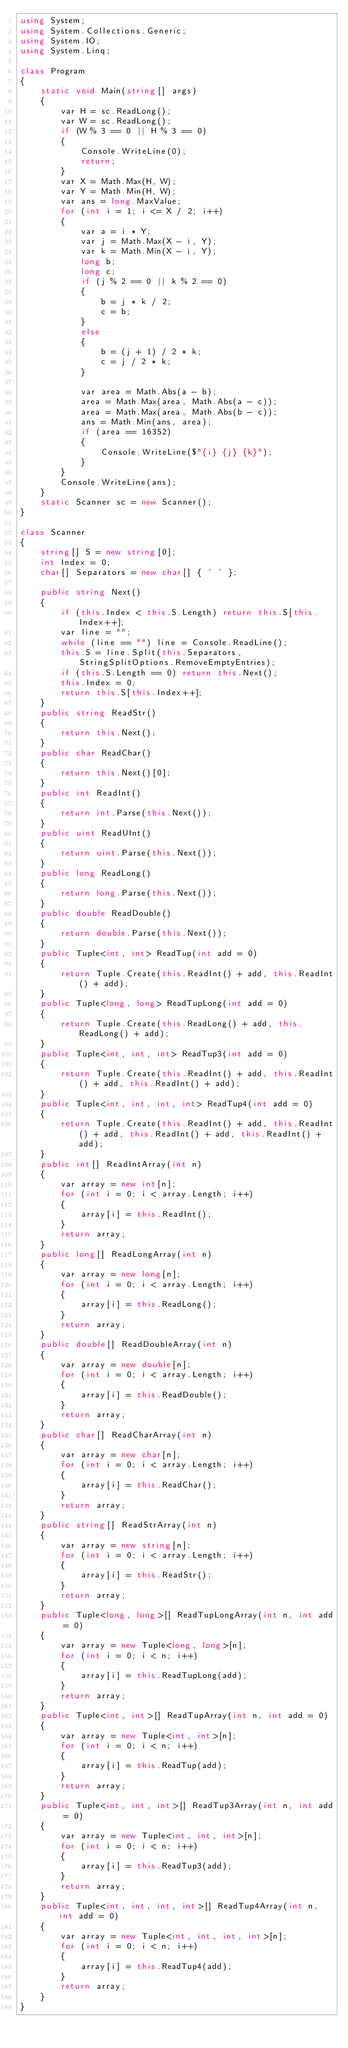<code> <loc_0><loc_0><loc_500><loc_500><_C#_>using System;
using System.Collections.Generic;
using System.IO;
using System.Linq;

class Program
{
    static void Main(string[] args)
    {
        var H = sc.ReadLong();
        var W = sc.ReadLong();
        if (W % 3 == 0 || H % 3 == 0)
        {
            Console.WriteLine(0);
            return;
        }
        var X = Math.Max(H, W);
        var Y = Math.Min(H, W);
        var ans = long.MaxValue;
        for (int i = 1; i <= X / 2; i++)
        {
            var a = i * Y;
            var j = Math.Max(X - i, Y);
            var k = Math.Min(X - i, Y);
            long b;
            long c;
            if (j % 2 == 0 || k % 2 == 0)
            {
                b = j * k / 2;
                c = b;
            }
            else
            {
                b = (j + 1) / 2 * k;
                c = j / 2 * k;
            }

            var area = Math.Abs(a - b);
            area = Math.Max(area, Math.Abs(a - c));
            area = Math.Max(area, Math.Abs(b - c));
            ans = Math.Min(ans, area);
            if (area == 16352)
            {
                Console.WriteLine($"{i} {j} {k}");
            }
        }
        Console.WriteLine(ans);
    }
    static Scanner sc = new Scanner();
}

class Scanner
{
    string[] S = new string[0];
    int Index = 0;
    char[] Separators = new char[] { ' ' };

    public string Next()
    {
        if (this.Index < this.S.Length) return this.S[this.Index++];
        var line = "";
        while (line == "") line = Console.ReadLine();
        this.S = line.Split(this.Separators, StringSplitOptions.RemoveEmptyEntries);
        if (this.S.Length == 0) return this.Next();
        this.Index = 0;
        return this.S[this.Index++];
    }
    public string ReadStr()
    {
        return this.Next();
    }
    public char ReadChar()
    {
        return this.Next()[0];
    }
    public int ReadInt()
    {
        return int.Parse(this.Next());
    }
    public uint ReadUInt()
    {
        return uint.Parse(this.Next());
    }
    public long ReadLong()
    {
        return long.Parse(this.Next());
    }
    public double ReadDouble()
    {
        return double.Parse(this.Next());
    }
    public Tuple<int, int> ReadTup(int add = 0)
    {
        return Tuple.Create(this.ReadInt() + add, this.ReadInt() + add);
    }
    public Tuple<long, long> ReadTupLong(int add = 0)
    {
        return Tuple.Create(this.ReadLong() + add, this.ReadLong() + add);
    }
    public Tuple<int, int, int> ReadTup3(int add = 0)
    {
        return Tuple.Create(this.ReadInt() + add, this.ReadInt() + add, this.ReadInt() + add);
    }
    public Tuple<int, int, int, int> ReadTup4(int add = 0)
    {
        return Tuple.Create(this.ReadInt() + add, this.ReadInt() + add, this.ReadInt() + add, this.ReadInt() + add);
    }
    public int[] ReadIntArray(int n)
    {
        var array = new int[n];
        for (int i = 0; i < array.Length; i++)
        {
            array[i] = this.ReadInt();
        }
        return array;
    }
    public long[] ReadLongArray(int n)
    {
        var array = new long[n];
        for (int i = 0; i < array.Length; i++)
        {
            array[i] = this.ReadLong();
        }
        return array;
    }
    public double[] ReadDoubleArray(int n)
    {
        var array = new double[n];
        for (int i = 0; i < array.Length; i++)
        {
            array[i] = this.ReadDouble();
        }
        return array;
    }
    public char[] ReadCharArray(int n)
    {
        var array = new char[n];
        for (int i = 0; i < array.Length; i++)
        {
            array[i] = this.ReadChar();
        }
        return array;
    }
    public string[] ReadStrArray(int n)
    {
        var array = new string[n];
        for (int i = 0; i < array.Length; i++)
        {
            array[i] = this.ReadStr();
        }
        return array;
    }
    public Tuple<long, long>[] ReadTupLongArray(int n, int add = 0)
    {
        var array = new Tuple<long, long>[n];
        for (int i = 0; i < n; i++)
        {
            array[i] = this.ReadTupLong(add);
        }
        return array;
    }
    public Tuple<int, int>[] ReadTupArray(int n, int add = 0)
    {
        var array = new Tuple<int, int>[n];
        for (int i = 0; i < n; i++)
        {
            array[i] = this.ReadTup(add);
        }
        return array;
    }
    public Tuple<int, int, int>[] ReadTup3Array(int n, int add = 0)
    {
        var array = new Tuple<int, int, int>[n];
        for (int i = 0; i < n; i++)
        {
            array[i] = this.ReadTup3(add);
        }
        return array;
    }
    public Tuple<int, int, int, int>[] ReadTup4Array(int n, int add = 0)
    {
        var array = new Tuple<int, int, int, int>[n];
        for (int i = 0; i < n; i++)
        {
            array[i] = this.ReadTup4(add);
        }
        return array;
    }
}
</code> 